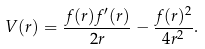<formula> <loc_0><loc_0><loc_500><loc_500>V ( r ) = \frac { f ( r ) f ^ { \prime } ( r ) } { 2 r } - \frac { f ( r ) ^ { 2 } } { 4 r ^ { 2 } } .</formula> 